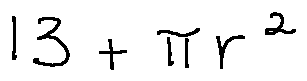<formula> <loc_0><loc_0><loc_500><loc_500>1 3 + \pi r ^ { 2 }</formula> 